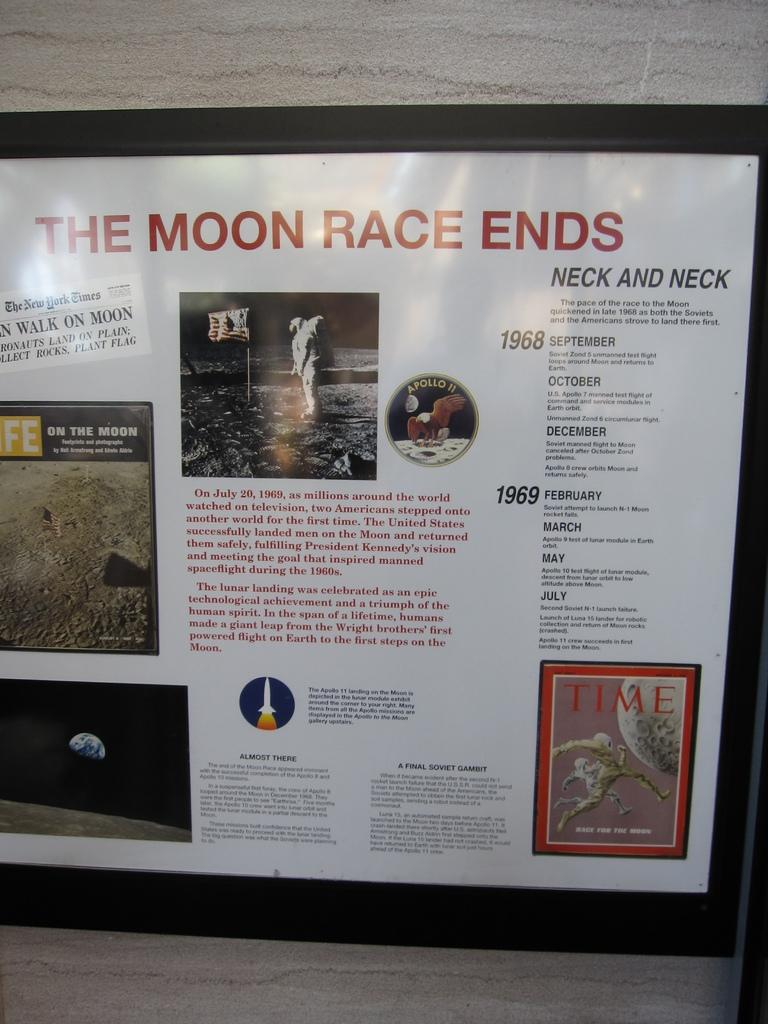<image>
Describe the image concisely. A poster with The moon race ends at to top of the poster. 